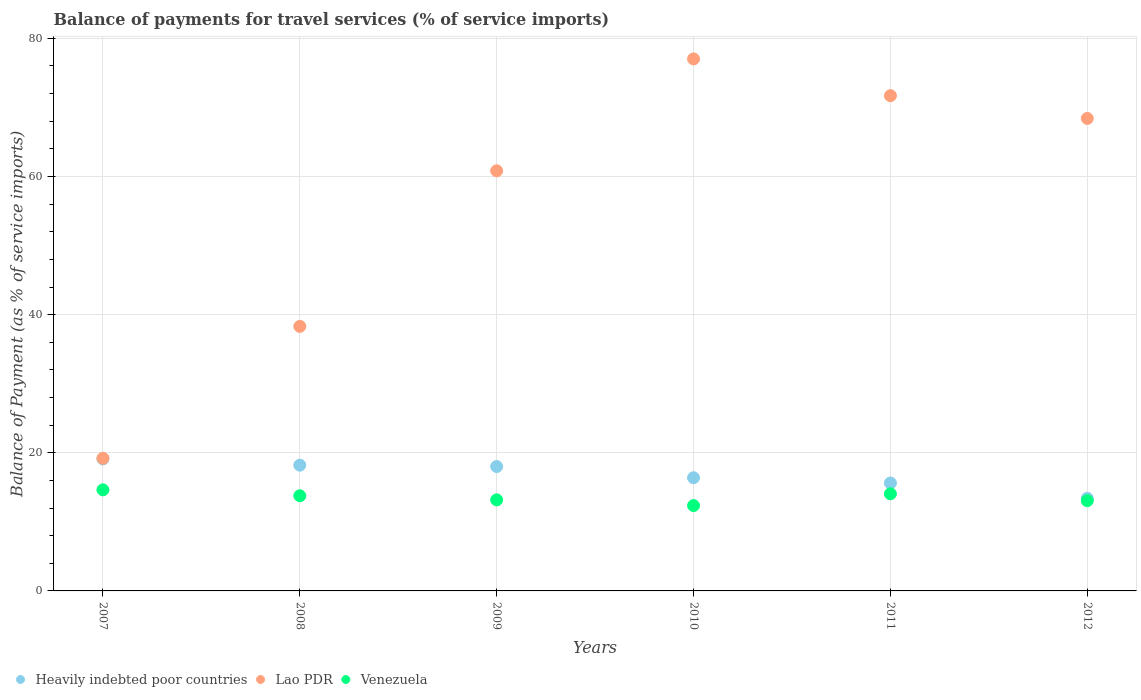Is the number of dotlines equal to the number of legend labels?
Your answer should be compact. Yes. What is the balance of payments for travel services in Heavily indebted poor countries in 2007?
Your response must be concise. 19.11. Across all years, what is the maximum balance of payments for travel services in Lao PDR?
Provide a short and direct response. 77.02. Across all years, what is the minimum balance of payments for travel services in Venezuela?
Ensure brevity in your answer.  12.36. In which year was the balance of payments for travel services in Venezuela minimum?
Ensure brevity in your answer.  2010. What is the total balance of payments for travel services in Lao PDR in the graph?
Your answer should be very brief. 335.46. What is the difference between the balance of payments for travel services in Lao PDR in 2008 and that in 2010?
Your answer should be very brief. -38.73. What is the difference between the balance of payments for travel services in Lao PDR in 2011 and the balance of payments for travel services in Heavily indebted poor countries in 2012?
Make the answer very short. 58.3. What is the average balance of payments for travel services in Venezuela per year?
Provide a short and direct response. 13.51. In the year 2008, what is the difference between the balance of payments for travel services in Lao PDR and balance of payments for travel services in Venezuela?
Offer a terse response. 24.52. What is the ratio of the balance of payments for travel services in Lao PDR in 2009 to that in 2010?
Your answer should be compact. 0.79. Is the balance of payments for travel services in Lao PDR in 2007 less than that in 2009?
Your answer should be very brief. Yes. Is the difference between the balance of payments for travel services in Lao PDR in 2008 and 2012 greater than the difference between the balance of payments for travel services in Venezuela in 2008 and 2012?
Provide a succinct answer. No. What is the difference between the highest and the second highest balance of payments for travel services in Venezuela?
Offer a very short reply. 0.57. What is the difference between the highest and the lowest balance of payments for travel services in Lao PDR?
Give a very brief answer. 57.82. In how many years, is the balance of payments for travel services in Heavily indebted poor countries greater than the average balance of payments for travel services in Heavily indebted poor countries taken over all years?
Your answer should be compact. 3. Is the balance of payments for travel services in Venezuela strictly greater than the balance of payments for travel services in Heavily indebted poor countries over the years?
Ensure brevity in your answer.  No. Is the balance of payments for travel services in Lao PDR strictly less than the balance of payments for travel services in Venezuela over the years?
Ensure brevity in your answer.  No. How many dotlines are there?
Offer a terse response. 3. Does the graph contain any zero values?
Your answer should be compact. No. Does the graph contain grids?
Your answer should be very brief. Yes. Where does the legend appear in the graph?
Provide a short and direct response. Bottom left. How are the legend labels stacked?
Provide a short and direct response. Horizontal. What is the title of the graph?
Offer a terse response. Balance of payments for travel services (% of service imports). What is the label or title of the X-axis?
Ensure brevity in your answer.  Years. What is the label or title of the Y-axis?
Keep it short and to the point. Balance of Payment (as % of service imports). What is the Balance of Payment (as % of service imports) of Heavily indebted poor countries in 2007?
Give a very brief answer. 19.11. What is the Balance of Payment (as % of service imports) of Lao PDR in 2007?
Your answer should be compact. 19.2. What is the Balance of Payment (as % of service imports) of Venezuela in 2007?
Give a very brief answer. 14.63. What is the Balance of Payment (as % of service imports) of Heavily indebted poor countries in 2008?
Your response must be concise. 18.21. What is the Balance of Payment (as % of service imports) of Lao PDR in 2008?
Provide a short and direct response. 38.3. What is the Balance of Payment (as % of service imports) of Venezuela in 2008?
Your answer should be very brief. 13.78. What is the Balance of Payment (as % of service imports) of Heavily indebted poor countries in 2009?
Provide a succinct answer. 18.01. What is the Balance of Payment (as % of service imports) in Lao PDR in 2009?
Your response must be concise. 60.83. What is the Balance of Payment (as % of service imports) in Venezuela in 2009?
Keep it short and to the point. 13.19. What is the Balance of Payment (as % of service imports) in Heavily indebted poor countries in 2010?
Make the answer very short. 16.39. What is the Balance of Payment (as % of service imports) in Lao PDR in 2010?
Give a very brief answer. 77.02. What is the Balance of Payment (as % of service imports) in Venezuela in 2010?
Offer a very short reply. 12.36. What is the Balance of Payment (as % of service imports) of Heavily indebted poor countries in 2011?
Your answer should be compact. 15.62. What is the Balance of Payment (as % of service imports) of Lao PDR in 2011?
Offer a very short reply. 71.7. What is the Balance of Payment (as % of service imports) in Venezuela in 2011?
Provide a succinct answer. 14.06. What is the Balance of Payment (as % of service imports) in Heavily indebted poor countries in 2012?
Provide a succinct answer. 13.4. What is the Balance of Payment (as % of service imports) in Lao PDR in 2012?
Provide a succinct answer. 68.41. What is the Balance of Payment (as % of service imports) in Venezuela in 2012?
Make the answer very short. 13.06. Across all years, what is the maximum Balance of Payment (as % of service imports) in Heavily indebted poor countries?
Your answer should be compact. 19.11. Across all years, what is the maximum Balance of Payment (as % of service imports) in Lao PDR?
Provide a succinct answer. 77.02. Across all years, what is the maximum Balance of Payment (as % of service imports) of Venezuela?
Make the answer very short. 14.63. Across all years, what is the minimum Balance of Payment (as % of service imports) of Heavily indebted poor countries?
Offer a terse response. 13.4. Across all years, what is the minimum Balance of Payment (as % of service imports) of Lao PDR?
Provide a short and direct response. 19.2. Across all years, what is the minimum Balance of Payment (as % of service imports) of Venezuela?
Offer a terse response. 12.36. What is the total Balance of Payment (as % of service imports) of Heavily indebted poor countries in the graph?
Your answer should be very brief. 100.73. What is the total Balance of Payment (as % of service imports) in Lao PDR in the graph?
Offer a terse response. 335.46. What is the total Balance of Payment (as % of service imports) in Venezuela in the graph?
Provide a succinct answer. 81.08. What is the difference between the Balance of Payment (as % of service imports) in Heavily indebted poor countries in 2007 and that in 2008?
Offer a very short reply. 0.9. What is the difference between the Balance of Payment (as % of service imports) of Lao PDR in 2007 and that in 2008?
Provide a short and direct response. -19.1. What is the difference between the Balance of Payment (as % of service imports) in Venezuela in 2007 and that in 2008?
Your response must be concise. 0.86. What is the difference between the Balance of Payment (as % of service imports) of Heavily indebted poor countries in 2007 and that in 2009?
Ensure brevity in your answer.  1.1. What is the difference between the Balance of Payment (as % of service imports) in Lao PDR in 2007 and that in 2009?
Make the answer very short. -41.63. What is the difference between the Balance of Payment (as % of service imports) of Venezuela in 2007 and that in 2009?
Provide a succinct answer. 1.45. What is the difference between the Balance of Payment (as % of service imports) of Heavily indebted poor countries in 2007 and that in 2010?
Your answer should be very brief. 2.72. What is the difference between the Balance of Payment (as % of service imports) in Lao PDR in 2007 and that in 2010?
Your answer should be very brief. -57.82. What is the difference between the Balance of Payment (as % of service imports) of Venezuela in 2007 and that in 2010?
Your response must be concise. 2.28. What is the difference between the Balance of Payment (as % of service imports) in Heavily indebted poor countries in 2007 and that in 2011?
Your response must be concise. 3.48. What is the difference between the Balance of Payment (as % of service imports) in Lao PDR in 2007 and that in 2011?
Your answer should be compact. -52.5. What is the difference between the Balance of Payment (as % of service imports) in Venezuela in 2007 and that in 2011?
Ensure brevity in your answer.  0.57. What is the difference between the Balance of Payment (as % of service imports) in Heavily indebted poor countries in 2007 and that in 2012?
Provide a short and direct response. 5.7. What is the difference between the Balance of Payment (as % of service imports) of Lao PDR in 2007 and that in 2012?
Your answer should be compact. -49.2. What is the difference between the Balance of Payment (as % of service imports) of Venezuela in 2007 and that in 2012?
Offer a very short reply. 1.57. What is the difference between the Balance of Payment (as % of service imports) of Heavily indebted poor countries in 2008 and that in 2009?
Your response must be concise. 0.2. What is the difference between the Balance of Payment (as % of service imports) in Lao PDR in 2008 and that in 2009?
Your answer should be very brief. -22.53. What is the difference between the Balance of Payment (as % of service imports) in Venezuela in 2008 and that in 2009?
Give a very brief answer. 0.59. What is the difference between the Balance of Payment (as % of service imports) in Heavily indebted poor countries in 2008 and that in 2010?
Offer a very short reply. 1.82. What is the difference between the Balance of Payment (as % of service imports) in Lao PDR in 2008 and that in 2010?
Provide a short and direct response. -38.73. What is the difference between the Balance of Payment (as % of service imports) of Venezuela in 2008 and that in 2010?
Keep it short and to the point. 1.42. What is the difference between the Balance of Payment (as % of service imports) of Heavily indebted poor countries in 2008 and that in 2011?
Your response must be concise. 2.58. What is the difference between the Balance of Payment (as % of service imports) of Lao PDR in 2008 and that in 2011?
Offer a very short reply. -33.4. What is the difference between the Balance of Payment (as % of service imports) of Venezuela in 2008 and that in 2011?
Make the answer very short. -0.29. What is the difference between the Balance of Payment (as % of service imports) in Heavily indebted poor countries in 2008 and that in 2012?
Keep it short and to the point. 4.8. What is the difference between the Balance of Payment (as % of service imports) in Lao PDR in 2008 and that in 2012?
Keep it short and to the point. -30.11. What is the difference between the Balance of Payment (as % of service imports) of Venezuela in 2008 and that in 2012?
Your response must be concise. 0.72. What is the difference between the Balance of Payment (as % of service imports) of Heavily indebted poor countries in 2009 and that in 2010?
Make the answer very short. 1.62. What is the difference between the Balance of Payment (as % of service imports) in Lao PDR in 2009 and that in 2010?
Make the answer very short. -16.2. What is the difference between the Balance of Payment (as % of service imports) in Venezuela in 2009 and that in 2010?
Provide a short and direct response. 0.83. What is the difference between the Balance of Payment (as % of service imports) in Heavily indebted poor countries in 2009 and that in 2011?
Offer a terse response. 2.38. What is the difference between the Balance of Payment (as % of service imports) in Lao PDR in 2009 and that in 2011?
Offer a terse response. -10.87. What is the difference between the Balance of Payment (as % of service imports) of Venezuela in 2009 and that in 2011?
Make the answer very short. -0.88. What is the difference between the Balance of Payment (as % of service imports) of Heavily indebted poor countries in 2009 and that in 2012?
Provide a short and direct response. 4.6. What is the difference between the Balance of Payment (as % of service imports) in Lao PDR in 2009 and that in 2012?
Keep it short and to the point. -7.58. What is the difference between the Balance of Payment (as % of service imports) in Venezuela in 2009 and that in 2012?
Keep it short and to the point. 0.12. What is the difference between the Balance of Payment (as % of service imports) in Heavily indebted poor countries in 2010 and that in 2011?
Offer a terse response. 0.76. What is the difference between the Balance of Payment (as % of service imports) of Lao PDR in 2010 and that in 2011?
Give a very brief answer. 5.32. What is the difference between the Balance of Payment (as % of service imports) of Venezuela in 2010 and that in 2011?
Offer a very short reply. -1.71. What is the difference between the Balance of Payment (as % of service imports) in Heavily indebted poor countries in 2010 and that in 2012?
Your answer should be very brief. 2.98. What is the difference between the Balance of Payment (as % of service imports) of Lao PDR in 2010 and that in 2012?
Keep it short and to the point. 8.62. What is the difference between the Balance of Payment (as % of service imports) in Venezuela in 2010 and that in 2012?
Provide a succinct answer. -0.71. What is the difference between the Balance of Payment (as % of service imports) in Heavily indebted poor countries in 2011 and that in 2012?
Your answer should be very brief. 2.22. What is the difference between the Balance of Payment (as % of service imports) of Lao PDR in 2011 and that in 2012?
Provide a short and direct response. 3.3. What is the difference between the Balance of Payment (as % of service imports) in Venezuela in 2011 and that in 2012?
Offer a very short reply. 1. What is the difference between the Balance of Payment (as % of service imports) in Heavily indebted poor countries in 2007 and the Balance of Payment (as % of service imports) in Lao PDR in 2008?
Give a very brief answer. -19.19. What is the difference between the Balance of Payment (as % of service imports) of Heavily indebted poor countries in 2007 and the Balance of Payment (as % of service imports) of Venezuela in 2008?
Offer a terse response. 5.33. What is the difference between the Balance of Payment (as % of service imports) in Lao PDR in 2007 and the Balance of Payment (as % of service imports) in Venezuela in 2008?
Your answer should be very brief. 5.42. What is the difference between the Balance of Payment (as % of service imports) in Heavily indebted poor countries in 2007 and the Balance of Payment (as % of service imports) in Lao PDR in 2009?
Provide a short and direct response. -41.72. What is the difference between the Balance of Payment (as % of service imports) in Heavily indebted poor countries in 2007 and the Balance of Payment (as % of service imports) in Venezuela in 2009?
Provide a short and direct response. 5.92. What is the difference between the Balance of Payment (as % of service imports) of Lao PDR in 2007 and the Balance of Payment (as % of service imports) of Venezuela in 2009?
Offer a very short reply. 6.02. What is the difference between the Balance of Payment (as % of service imports) in Heavily indebted poor countries in 2007 and the Balance of Payment (as % of service imports) in Lao PDR in 2010?
Give a very brief answer. -57.92. What is the difference between the Balance of Payment (as % of service imports) of Heavily indebted poor countries in 2007 and the Balance of Payment (as % of service imports) of Venezuela in 2010?
Keep it short and to the point. 6.75. What is the difference between the Balance of Payment (as % of service imports) of Lao PDR in 2007 and the Balance of Payment (as % of service imports) of Venezuela in 2010?
Your answer should be very brief. 6.85. What is the difference between the Balance of Payment (as % of service imports) of Heavily indebted poor countries in 2007 and the Balance of Payment (as % of service imports) of Lao PDR in 2011?
Your response must be concise. -52.6. What is the difference between the Balance of Payment (as % of service imports) of Heavily indebted poor countries in 2007 and the Balance of Payment (as % of service imports) of Venezuela in 2011?
Your answer should be very brief. 5.04. What is the difference between the Balance of Payment (as % of service imports) in Lao PDR in 2007 and the Balance of Payment (as % of service imports) in Venezuela in 2011?
Your answer should be compact. 5.14. What is the difference between the Balance of Payment (as % of service imports) in Heavily indebted poor countries in 2007 and the Balance of Payment (as % of service imports) in Lao PDR in 2012?
Provide a short and direct response. -49.3. What is the difference between the Balance of Payment (as % of service imports) in Heavily indebted poor countries in 2007 and the Balance of Payment (as % of service imports) in Venezuela in 2012?
Your answer should be compact. 6.04. What is the difference between the Balance of Payment (as % of service imports) in Lao PDR in 2007 and the Balance of Payment (as % of service imports) in Venezuela in 2012?
Provide a short and direct response. 6.14. What is the difference between the Balance of Payment (as % of service imports) in Heavily indebted poor countries in 2008 and the Balance of Payment (as % of service imports) in Lao PDR in 2009?
Provide a succinct answer. -42.62. What is the difference between the Balance of Payment (as % of service imports) in Heavily indebted poor countries in 2008 and the Balance of Payment (as % of service imports) in Venezuela in 2009?
Your answer should be very brief. 5.02. What is the difference between the Balance of Payment (as % of service imports) of Lao PDR in 2008 and the Balance of Payment (as % of service imports) of Venezuela in 2009?
Your answer should be very brief. 25.11. What is the difference between the Balance of Payment (as % of service imports) in Heavily indebted poor countries in 2008 and the Balance of Payment (as % of service imports) in Lao PDR in 2010?
Give a very brief answer. -58.82. What is the difference between the Balance of Payment (as % of service imports) of Heavily indebted poor countries in 2008 and the Balance of Payment (as % of service imports) of Venezuela in 2010?
Your answer should be very brief. 5.85. What is the difference between the Balance of Payment (as % of service imports) of Lao PDR in 2008 and the Balance of Payment (as % of service imports) of Venezuela in 2010?
Ensure brevity in your answer.  25.94. What is the difference between the Balance of Payment (as % of service imports) of Heavily indebted poor countries in 2008 and the Balance of Payment (as % of service imports) of Lao PDR in 2011?
Offer a terse response. -53.5. What is the difference between the Balance of Payment (as % of service imports) of Heavily indebted poor countries in 2008 and the Balance of Payment (as % of service imports) of Venezuela in 2011?
Provide a succinct answer. 4.14. What is the difference between the Balance of Payment (as % of service imports) of Lao PDR in 2008 and the Balance of Payment (as % of service imports) of Venezuela in 2011?
Ensure brevity in your answer.  24.24. What is the difference between the Balance of Payment (as % of service imports) of Heavily indebted poor countries in 2008 and the Balance of Payment (as % of service imports) of Lao PDR in 2012?
Offer a very short reply. -50.2. What is the difference between the Balance of Payment (as % of service imports) in Heavily indebted poor countries in 2008 and the Balance of Payment (as % of service imports) in Venezuela in 2012?
Offer a very short reply. 5.14. What is the difference between the Balance of Payment (as % of service imports) of Lao PDR in 2008 and the Balance of Payment (as % of service imports) of Venezuela in 2012?
Keep it short and to the point. 25.24. What is the difference between the Balance of Payment (as % of service imports) in Heavily indebted poor countries in 2009 and the Balance of Payment (as % of service imports) in Lao PDR in 2010?
Make the answer very short. -59.02. What is the difference between the Balance of Payment (as % of service imports) of Heavily indebted poor countries in 2009 and the Balance of Payment (as % of service imports) of Venezuela in 2010?
Provide a short and direct response. 5.65. What is the difference between the Balance of Payment (as % of service imports) of Lao PDR in 2009 and the Balance of Payment (as % of service imports) of Venezuela in 2010?
Provide a succinct answer. 48.47. What is the difference between the Balance of Payment (as % of service imports) of Heavily indebted poor countries in 2009 and the Balance of Payment (as % of service imports) of Lao PDR in 2011?
Your answer should be very brief. -53.69. What is the difference between the Balance of Payment (as % of service imports) of Heavily indebted poor countries in 2009 and the Balance of Payment (as % of service imports) of Venezuela in 2011?
Your answer should be very brief. 3.94. What is the difference between the Balance of Payment (as % of service imports) in Lao PDR in 2009 and the Balance of Payment (as % of service imports) in Venezuela in 2011?
Your response must be concise. 46.76. What is the difference between the Balance of Payment (as % of service imports) of Heavily indebted poor countries in 2009 and the Balance of Payment (as % of service imports) of Lao PDR in 2012?
Make the answer very short. -50.4. What is the difference between the Balance of Payment (as % of service imports) in Heavily indebted poor countries in 2009 and the Balance of Payment (as % of service imports) in Venezuela in 2012?
Make the answer very short. 4.95. What is the difference between the Balance of Payment (as % of service imports) of Lao PDR in 2009 and the Balance of Payment (as % of service imports) of Venezuela in 2012?
Your answer should be very brief. 47.77. What is the difference between the Balance of Payment (as % of service imports) in Heavily indebted poor countries in 2010 and the Balance of Payment (as % of service imports) in Lao PDR in 2011?
Make the answer very short. -55.31. What is the difference between the Balance of Payment (as % of service imports) of Heavily indebted poor countries in 2010 and the Balance of Payment (as % of service imports) of Venezuela in 2011?
Keep it short and to the point. 2.32. What is the difference between the Balance of Payment (as % of service imports) in Lao PDR in 2010 and the Balance of Payment (as % of service imports) in Venezuela in 2011?
Your answer should be compact. 62.96. What is the difference between the Balance of Payment (as % of service imports) of Heavily indebted poor countries in 2010 and the Balance of Payment (as % of service imports) of Lao PDR in 2012?
Offer a very short reply. -52.02. What is the difference between the Balance of Payment (as % of service imports) of Heavily indebted poor countries in 2010 and the Balance of Payment (as % of service imports) of Venezuela in 2012?
Your response must be concise. 3.32. What is the difference between the Balance of Payment (as % of service imports) of Lao PDR in 2010 and the Balance of Payment (as % of service imports) of Venezuela in 2012?
Offer a very short reply. 63.96. What is the difference between the Balance of Payment (as % of service imports) in Heavily indebted poor countries in 2011 and the Balance of Payment (as % of service imports) in Lao PDR in 2012?
Offer a very short reply. -52.78. What is the difference between the Balance of Payment (as % of service imports) of Heavily indebted poor countries in 2011 and the Balance of Payment (as % of service imports) of Venezuela in 2012?
Keep it short and to the point. 2.56. What is the difference between the Balance of Payment (as % of service imports) of Lao PDR in 2011 and the Balance of Payment (as % of service imports) of Venezuela in 2012?
Ensure brevity in your answer.  58.64. What is the average Balance of Payment (as % of service imports) of Heavily indebted poor countries per year?
Provide a short and direct response. 16.79. What is the average Balance of Payment (as % of service imports) in Lao PDR per year?
Provide a succinct answer. 55.91. What is the average Balance of Payment (as % of service imports) in Venezuela per year?
Provide a succinct answer. 13.51. In the year 2007, what is the difference between the Balance of Payment (as % of service imports) in Heavily indebted poor countries and Balance of Payment (as % of service imports) in Lao PDR?
Your answer should be compact. -0.1. In the year 2007, what is the difference between the Balance of Payment (as % of service imports) of Heavily indebted poor countries and Balance of Payment (as % of service imports) of Venezuela?
Provide a short and direct response. 4.47. In the year 2007, what is the difference between the Balance of Payment (as % of service imports) of Lao PDR and Balance of Payment (as % of service imports) of Venezuela?
Keep it short and to the point. 4.57. In the year 2008, what is the difference between the Balance of Payment (as % of service imports) of Heavily indebted poor countries and Balance of Payment (as % of service imports) of Lao PDR?
Offer a terse response. -20.09. In the year 2008, what is the difference between the Balance of Payment (as % of service imports) in Heavily indebted poor countries and Balance of Payment (as % of service imports) in Venezuela?
Ensure brevity in your answer.  4.43. In the year 2008, what is the difference between the Balance of Payment (as % of service imports) of Lao PDR and Balance of Payment (as % of service imports) of Venezuela?
Ensure brevity in your answer.  24.52. In the year 2009, what is the difference between the Balance of Payment (as % of service imports) in Heavily indebted poor countries and Balance of Payment (as % of service imports) in Lao PDR?
Offer a very short reply. -42.82. In the year 2009, what is the difference between the Balance of Payment (as % of service imports) in Heavily indebted poor countries and Balance of Payment (as % of service imports) in Venezuela?
Make the answer very short. 4.82. In the year 2009, what is the difference between the Balance of Payment (as % of service imports) in Lao PDR and Balance of Payment (as % of service imports) in Venezuela?
Keep it short and to the point. 47.64. In the year 2010, what is the difference between the Balance of Payment (as % of service imports) of Heavily indebted poor countries and Balance of Payment (as % of service imports) of Lao PDR?
Your response must be concise. -60.64. In the year 2010, what is the difference between the Balance of Payment (as % of service imports) of Heavily indebted poor countries and Balance of Payment (as % of service imports) of Venezuela?
Keep it short and to the point. 4.03. In the year 2010, what is the difference between the Balance of Payment (as % of service imports) of Lao PDR and Balance of Payment (as % of service imports) of Venezuela?
Your answer should be compact. 64.67. In the year 2011, what is the difference between the Balance of Payment (as % of service imports) of Heavily indebted poor countries and Balance of Payment (as % of service imports) of Lao PDR?
Offer a terse response. -56.08. In the year 2011, what is the difference between the Balance of Payment (as % of service imports) in Heavily indebted poor countries and Balance of Payment (as % of service imports) in Venezuela?
Give a very brief answer. 1.56. In the year 2011, what is the difference between the Balance of Payment (as % of service imports) of Lao PDR and Balance of Payment (as % of service imports) of Venezuela?
Keep it short and to the point. 57.64. In the year 2012, what is the difference between the Balance of Payment (as % of service imports) in Heavily indebted poor countries and Balance of Payment (as % of service imports) in Lao PDR?
Give a very brief answer. -55. In the year 2012, what is the difference between the Balance of Payment (as % of service imports) of Heavily indebted poor countries and Balance of Payment (as % of service imports) of Venezuela?
Give a very brief answer. 0.34. In the year 2012, what is the difference between the Balance of Payment (as % of service imports) of Lao PDR and Balance of Payment (as % of service imports) of Venezuela?
Provide a short and direct response. 55.34. What is the ratio of the Balance of Payment (as % of service imports) of Heavily indebted poor countries in 2007 to that in 2008?
Offer a terse response. 1.05. What is the ratio of the Balance of Payment (as % of service imports) in Lao PDR in 2007 to that in 2008?
Give a very brief answer. 0.5. What is the ratio of the Balance of Payment (as % of service imports) of Venezuela in 2007 to that in 2008?
Keep it short and to the point. 1.06. What is the ratio of the Balance of Payment (as % of service imports) of Heavily indebted poor countries in 2007 to that in 2009?
Ensure brevity in your answer.  1.06. What is the ratio of the Balance of Payment (as % of service imports) in Lao PDR in 2007 to that in 2009?
Ensure brevity in your answer.  0.32. What is the ratio of the Balance of Payment (as % of service imports) of Venezuela in 2007 to that in 2009?
Provide a succinct answer. 1.11. What is the ratio of the Balance of Payment (as % of service imports) of Heavily indebted poor countries in 2007 to that in 2010?
Your answer should be compact. 1.17. What is the ratio of the Balance of Payment (as % of service imports) of Lao PDR in 2007 to that in 2010?
Give a very brief answer. 0.25. What is the ratio of the Balance of Payment (as % of service imports) of Venezuela in 2007 to that in 2010?
Your answer should be compact. 1.18. What is the ratio of the Balance of Payment (as % of service imports) of Heavily indebted poor countries in 2007 to that in 2011?
Provide a succinct answer. 1.22. What is the ratio of the Balance of Payment (as % of service imports) of Lao PDR in 2007 to that in 2011?
Offer a very short reply. 0.27. What is the ratio of the Balance of Payment (as % of service imports) in Venezuela in 2007 to that in 2011?
Offer a terse response. 1.04. What is the ratio of the Balance of Payment (as % of service imports) of Heavily indebted poor countries in 2007 to that in 2012?
Keep it short and to the point. 1.43. What is the ratio of the Balance of Payment (as % of service imports) in Lao PDR in 2007 to that in 2012?
Your answer should be very brief. 0.28. What is the ratio of the Balance of Payment (as % of service imports) of Venezuela in 2007 to that in 2012?
Offer a terse response. 1.12. What is the ratio of the Balance of Payment (as % of service imports) in Heavily indebted poor countries in 2008 to that in 2009?
Keep it short and to the point. 1.01. What is the ratio of the Balance of Payment (as % of service imports) in Lao PDR in 2008 to that in 2009?
Your answer should be very brief. 0.63. What is the ratio of the Balance of Payment (as % of service imports) in Venezuela in 2008 to that in 2009?
Provide a succinct answer. 1.04. What is the ratio of the Balance of Payment (as % of service imports) of Heavily indebted poor countries in 2008 to that in 2010?
Your response must be concise. 1.11. What is the ratio of the Balance of Payment (as % of service imports) of Lao PDR in 2008 to that in 2010?
Offer a very short reply. 0.5. What is the ratio of the Balance of Payment (as % of service imports) of Venezuela in 2008 to that in 2010?
Provide a short and direct response. 1.12. What is the ratio of the Balance of Payment (as % of service imports) of Heavily indebted poor countries in 2008 to that in 2011?
Keep it short and to the point. 1.17. What is the ratio of the Balance of Payment (as % of service imports) of Lao PDR in 2008 to that in 2011?
Ensure brevity in your answer.  0.53. What is the ratio of the Balance of Payment (as % of service imports) in Venezuela in 2008 to that in 2011?
Offer a very short reply. 0.98. What is the ratio of the Balance of Payment (as % of service imports) of Heavily indebted poor countries in 2008 to that in 2012?
Your response must be concise. 1.36. What is the ratio of the Balance of Payment (as % of service imports) in Lao PDR in 2008 to that in 2012?
Make the answer very short. 0.56. What is the ratio of the Balance of Payment (as % of service imports) in Venezuela in 2008 to that in 2012?
Provide a short and direct response. 1.05. What is the ratio of the Balance of Payment (as % of service imports) in Heavily indebted poor countries in 2009 to that in 2010?
Provide a short and direct response. 1.1. What is the ratio of the Balance of Payment (as % of service imports) in Lao PDR in 2009 to that in 2010?
Your answer should be very brief. 0.79. What is the ratio of the Balance of Payment (as % of service imports) of Venezuela in 2009 to that in 2010?
Make the answer very short. 1.07. What is the ratio of the Balance of Payment (as % of service imports) of Heavily indebted poor countries in 2009 to that in 2011?
Offer a very short reply. 1.15. What is the ratio of the Balance of Payment (as % of service imports) of Lao PDR in 2009 to that in 2011?
Your response must be concise. 0.85. What is the ratio of the Balance of Payment (as % of service imports) in Venezuela in 2009 to that in 2011?
Your answer should be very brief. 0.94. What is the ratio of the Balance of Payment (as % of service imports) in Heavily indebted poor countries in 2009 to that in 2012?
Offer a terse response. 1.34. What is the ratio of the Balance of Payment (as % of service imports) of Lao PDR in 2009 to that in 2012?
Offer a terse response. 0.89. What is the ratio of the Balance of Payment (as % of service imports) of Venezuela in 2009 to that in 2012?
Keep it short and to the point. 1.01. What is the ratio of the Balance of Payment (as % of service imports) of Heavily indebted poor countries in 2010 to that in 2011?
Provide a succinct answer. 1.05. What is the ratio of the Balance of Payment (as % of service imports) in Lao PDR in 2010 to that in 2011?
Keep it short and to the point. 1.07. What is the ratio of the Balance of Payment (as % of service imports) in Venezuela in 2010 to that in 2011?
Your answer should be compact. 0.88. What is the ratio of the Balance of Payment (as % of service imports) in Heavily indebted poor countries in 2010 to that in 2012?
Make the answer very short. 1.22. What is the ratio of the Balance of Payment (as % of service imports) of Lao PDR in 2010 to that in 2012?
Your answer should be very brief. 1.13. What is the ratio of the Balance of Payment (as % of service imports) of Venezuela in 2010 to that in 2012?
Your answer should be compact. 0.95. What is the ratio of the Balance of Payment (as % of service imports) in Heavily indebted poor countries in 2011 to that in 2012?
Provide a short and direct response. 1.17. What is the ratio of the Balance of Payment (as % of service imports) of Lao PDR in 2011 to that in 2012?
Your response must be concise. 1.05. What is the ratio of the Balance of Payment (as % of service imports) of Venezuela in 2011 to that in 2012?
Your response must be concise. 1.08. What is the difference between the highest and the second highest Balance of Payment (as % of service imports) in Heavily indebted poor countries?
Offer a terse response. 0.9. What is the difference between the highest and the second highest Balance of Payment (as % of service imports) of Lao PDR?
Offer a very short reply. 5.32. What is the difference between the highest and the second highest Balance of Payment (as % of service imports) of Venezuela?
Provide a succinct answer. 0.57. What is the difference between the highest and the lowest Balance of Payment (as % of service imports) in Heavily indebted poor countries?
Offer a very short reply. 5.7. What is the difference between the highest and the lowest Balance of Payment (as % of service imports) in Lao PDR?
Keep it short and to the point. 57.82. What is the difference between the highest and the lowest Balance of Payment (as % of service imports) of Venezuela?
Provide a succinct answer. 2.28. 